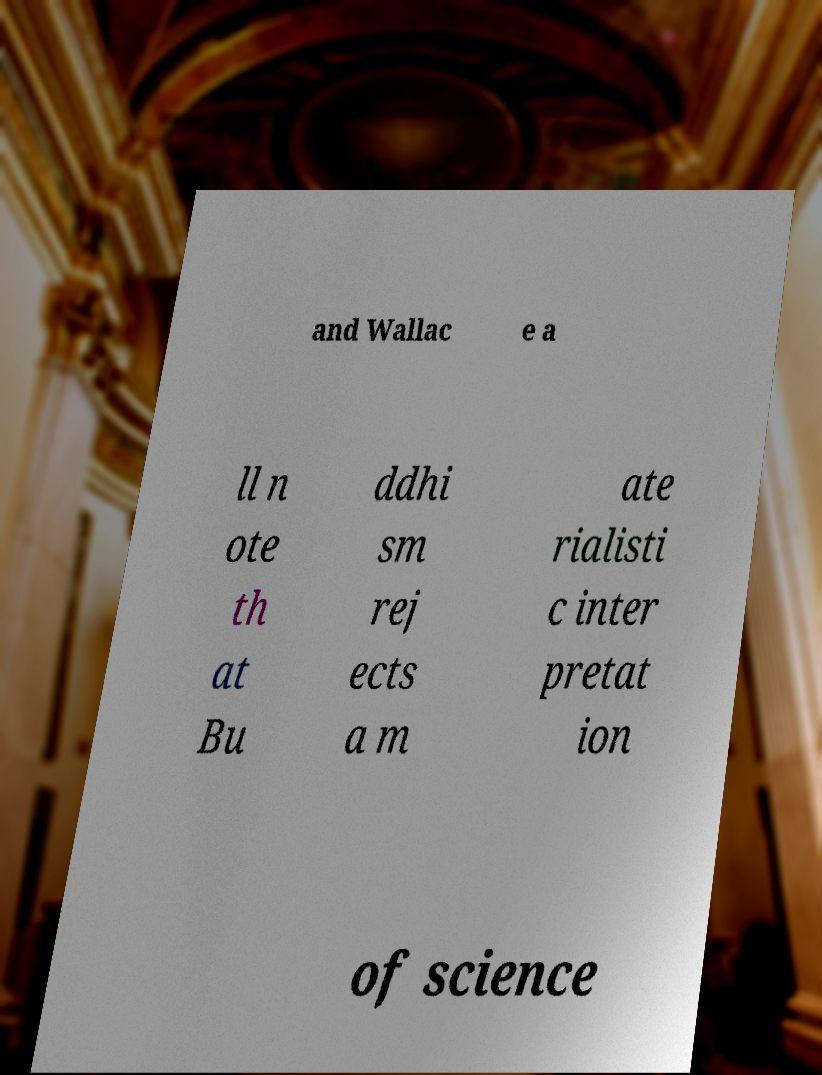I need the written content from this picture converted into text. Can you do that? and Wallac e a ll n ote th at Bu ddhi sm rej ects a m ate rialisti c inter pretat ion of science 